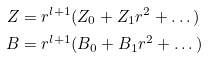Convert formula to latex. <formula><loc_0><loc_0><loc_500><loc_500>Z & = r ^ { l + 1 } ( Z _ { 0 } + Z _ { 1 } r ^ { 2 } + \dots \, ) \\ B & = r ^ { l + 1 } ( B _ { 0 } + B _ { 1 } r ^ { 2 } + \dots \, )</formula> 